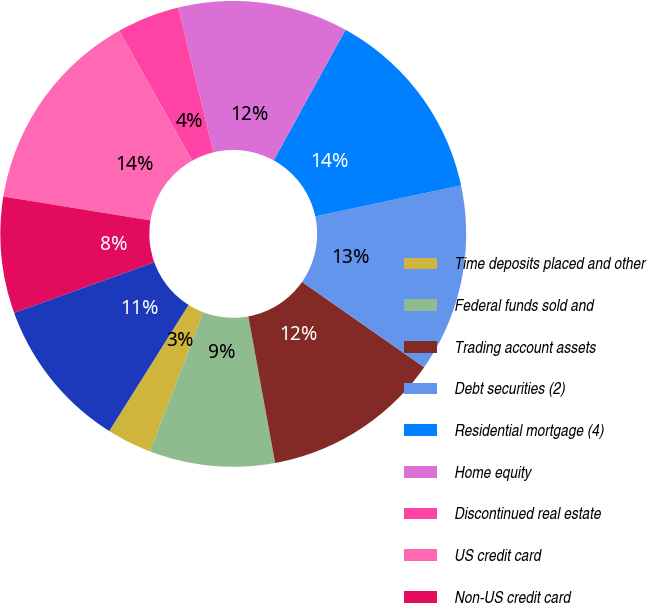Convert chart. <chart><loc_0><loc_0><loc_500><loc_500><pie_chart><fcel>Time deposits placed and other<fcel>Federal funds sold and<fcel>Trading account assets<fcel>Debt securities (2)<fcel>Residential mortgage (4)<fcel>Home equity<fcel>Discontinued real estate<fcel>US credit card<fcel>Non-US credit card<fcel>Direct/Indirect consumer (5)<nl><fcel>3.11%<fcel>8.7%<fcel>12.42%<fcel>13.04%<fcel>13.66%<fcel>11.8%<fcel>4.35%<fcel>14.29%<fcel>8.07%<fcel>10.56%<nl></chart> 